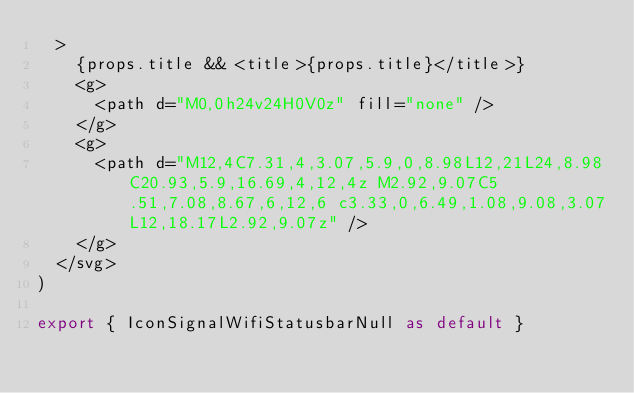<code> <loc_0><loc_0><loc_500><loc_500><_TypeScript_>  >
    {props.title && <title>{props.title}</title>}
    <g>
      <path d="M0,0h24v24H0V0z" fill="none" />
    </g>
    <g>
      <path d="M12,4C7.31,4,3.07,5.9,0,8.98L12,21L24,8.98C20.93,5.9,16.69,4,12,4z M2.92,9.07C5.51,7.08,8.67,6,12,6 c3.33,0,6.49,1.08,9.08,3.07L12,18.17L2.92,9.07z" />
    </g>
  </svg>
)

export { IconSignalWifiStatusbarNull as default }
</code> 